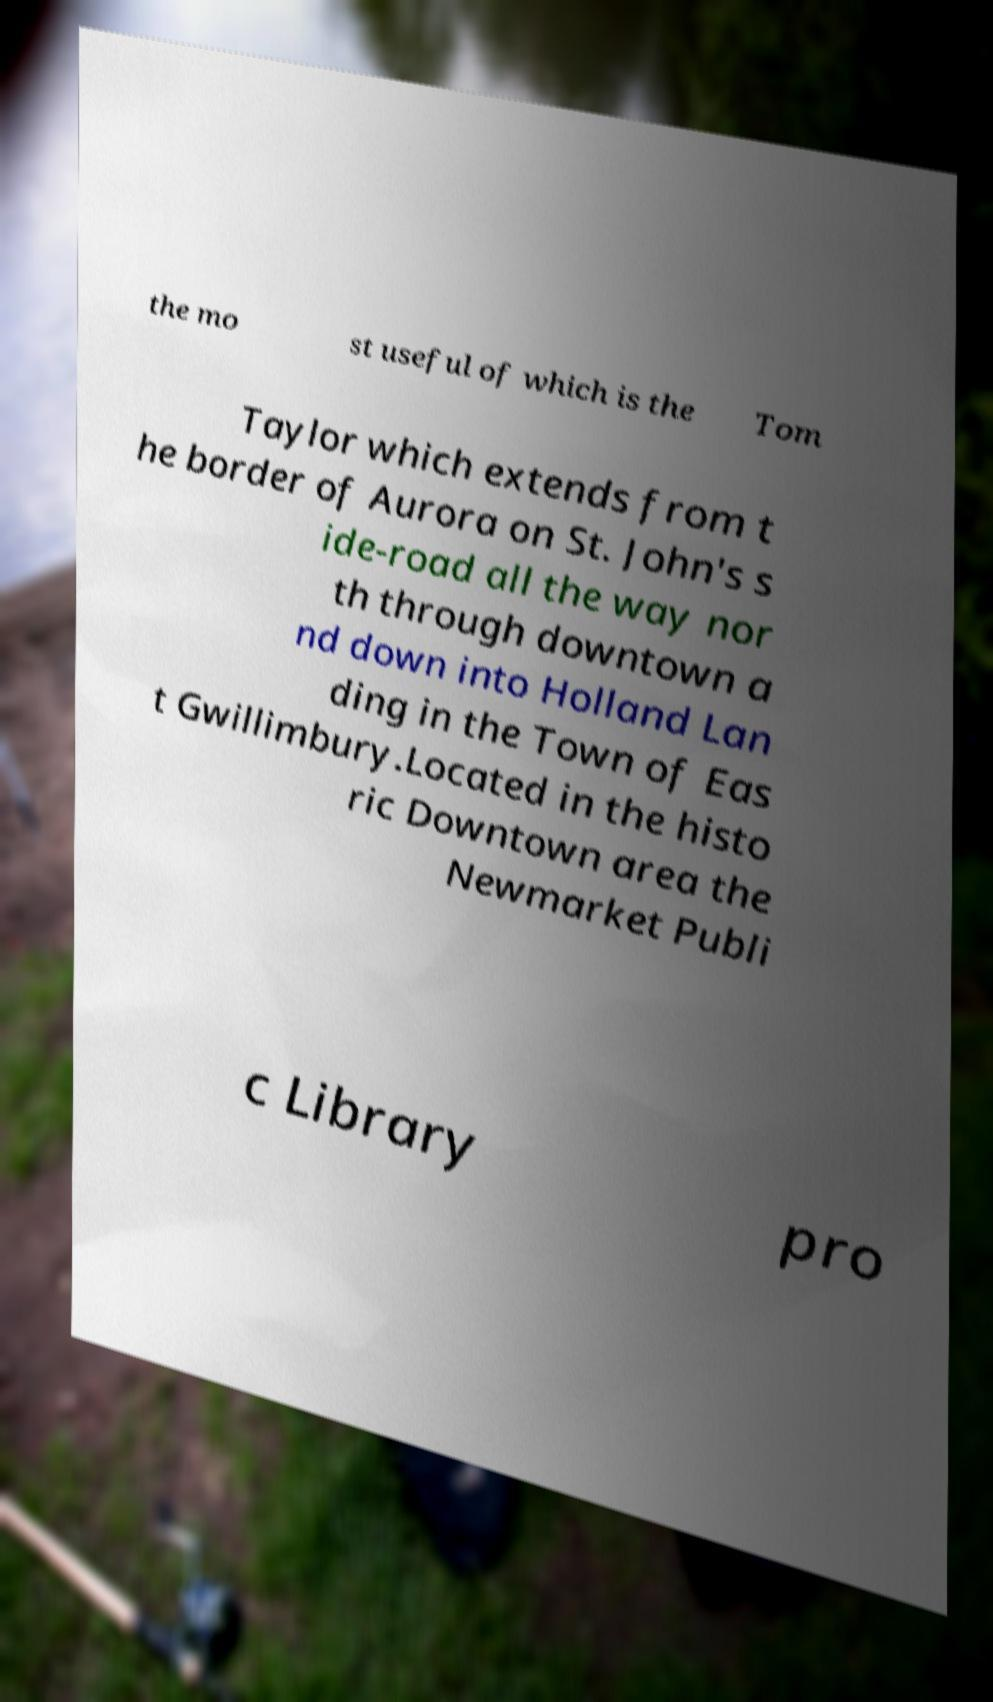What messages or text are displayed in this image? I need them in a readable, typed format. the mo st useful of which is the Tom Taylor which extends from t he border of Aurora on St. John's s ide-road all the way nor th through downtown a nd down into Holland Lan ding in the Town of Eas t Gwillimbury.Located in the histo ric Downtown area the Newmarket Publi c Library pro 